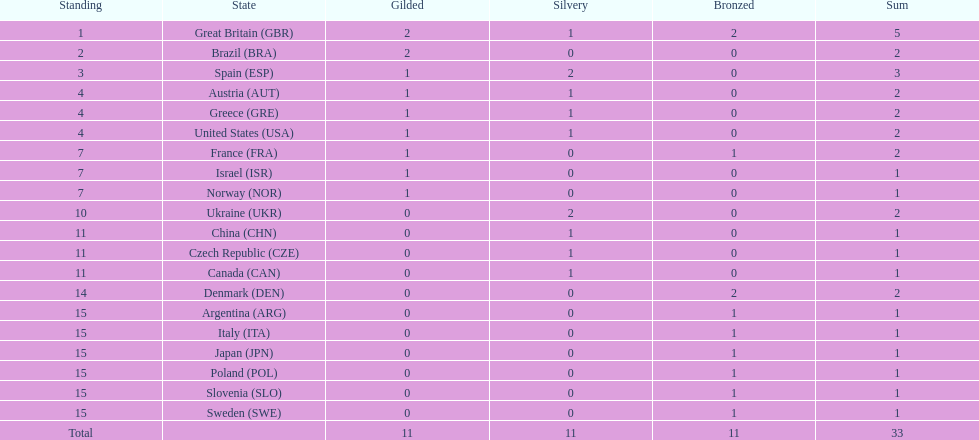How many countries won at least 1 gold and 1 silver medal? 5. 